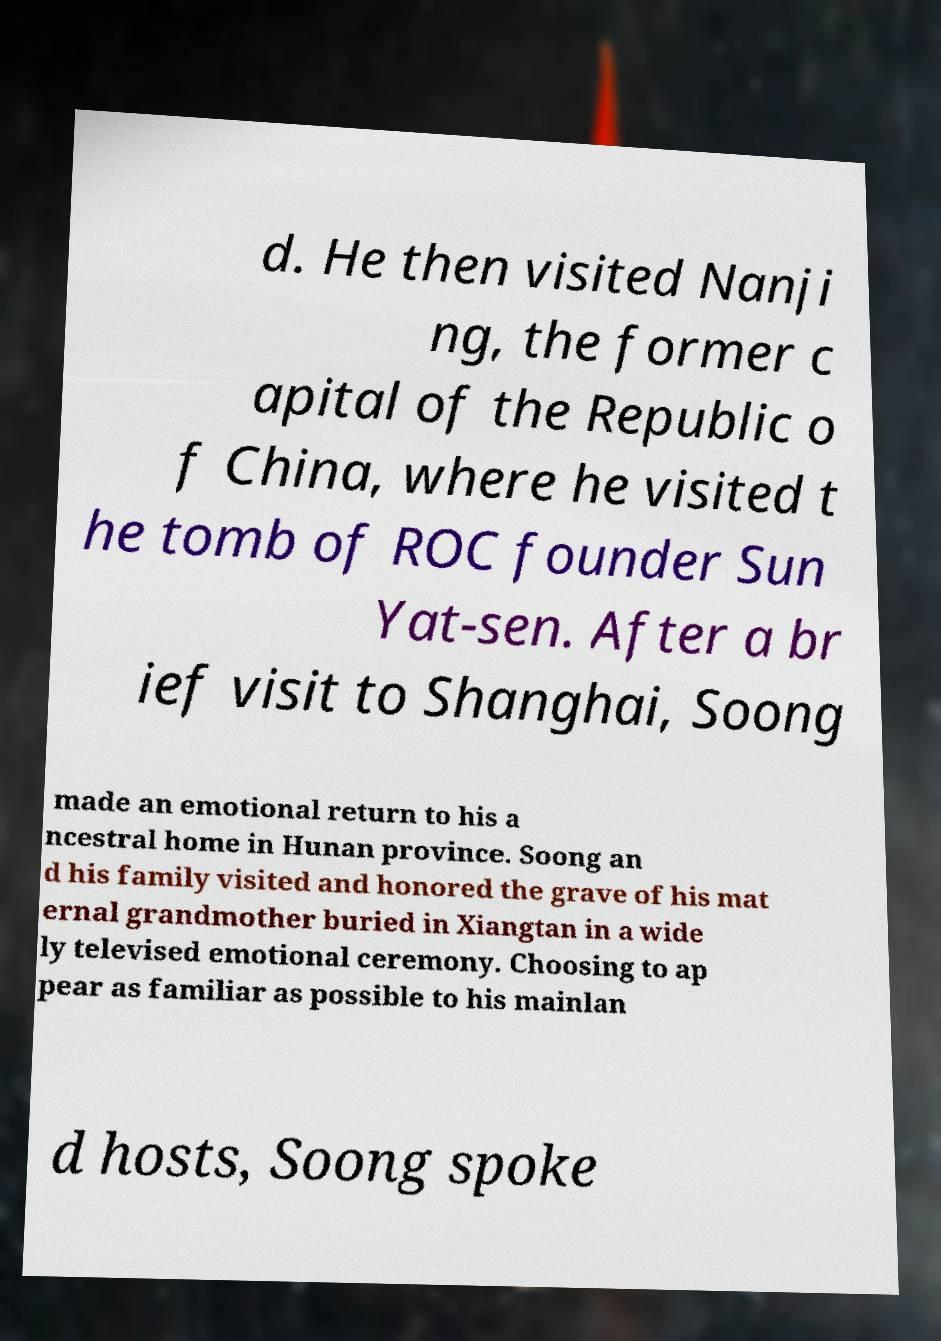I need the written content from this picture converted into text. Can you do that? d. He then visited Nanji ng, the former c apital of the Republic o f China, where he visited t he tomb of ROC founder Sun Yat-sen. After a br ief visit to Shanghai, Soong made an emotional return to his a ncestral home in Hunan province. Soong an d his family visited and honored the grave of his mat ernal grandmother buried in Xiangtan in a wide ly televised emotional ceremony. Choosing to ap pear as familiar as possible to his mainlan d hosts, Soong spoke 